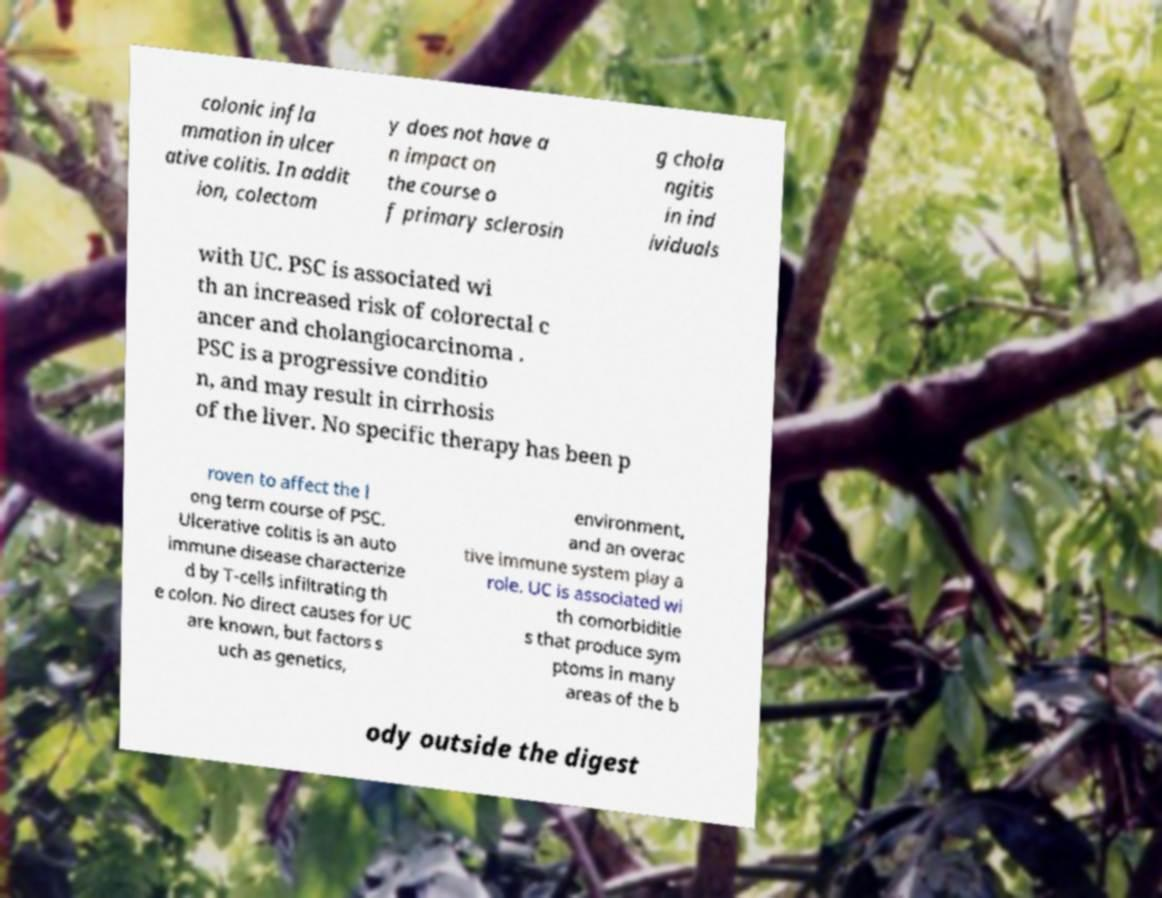Can you read and provide the text displayed in the image?This photo seems to have some interesting text. Can you extract and type it out for me? colonic infla mmation in ulcer ative colitis. In addit ion, colectom y does not have a n impact on the course o f primary sclerosin g chola ngitis in ind ividuals with UC. PSC is associated wi th an increased risk of colorectal c ancer and cholangiocarcinoma . PSC is a progressive conditio n, and may result in cirrhosis of the liver. No specific therapy has been p roven to affect the l ong term course of PSC. Ulcerative colitis is an auto immune disease characterize d by T-cells infiltrating th e colon. No direct causes for UC are known, but factors s uch as genetics, environment, and an overac tive immune system play a role. UC is associated wi th comorbiditie s that produce sym ptoms in many areas of the b ody outside the digest 